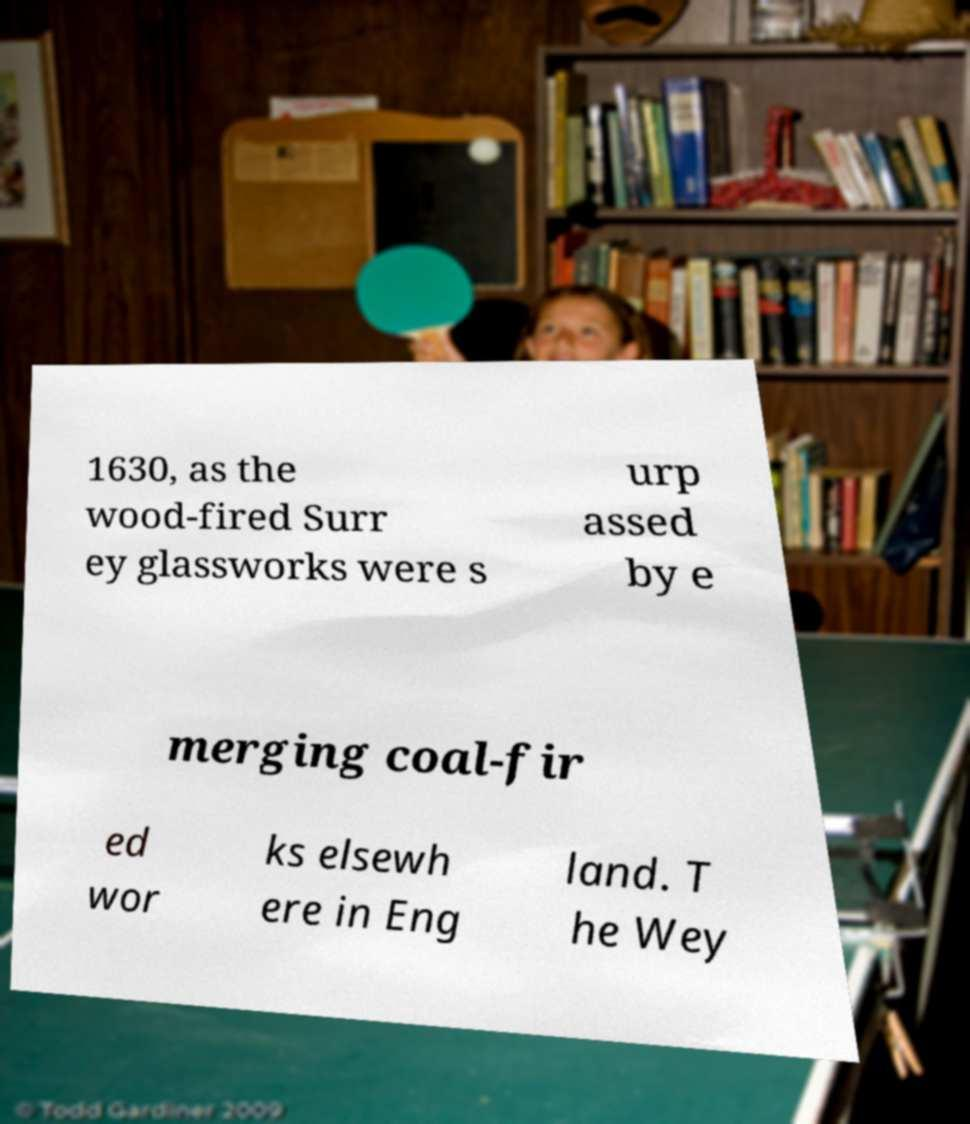What messages or text are displayed in this image? I need them in a readable, typed format. 1630, as the wood-fired Surr ey glassworks were s urp assed by e merging coal-fir ed wor ks elsewh ere in Eng land. T he Wey 